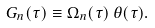Convert formula to latex. <formula><loc_0><loc_0><loc_500><loc_500>G _ { n } ( \tau ) \equiv \Omega _ { n } ( \tau ) \, \theta ( \tau ) .</formula> 